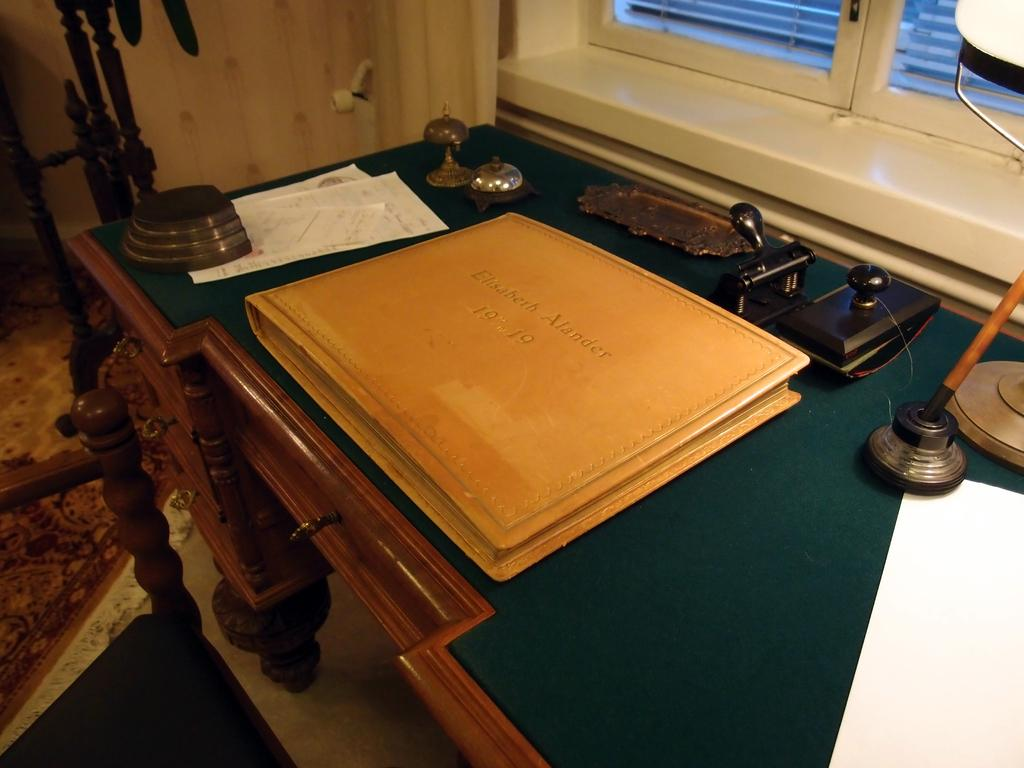What piece of furniture is present in the image? There is a table in the image. What object is placed on the table? There is a file on the table. What is written on the file? The file is labeled "connect." What can be seen in the background of the image? There is a window in the background of the image. Can you see any kites flying outside the window in the image? There is no kite visible in the image; only a window is present in the background. 